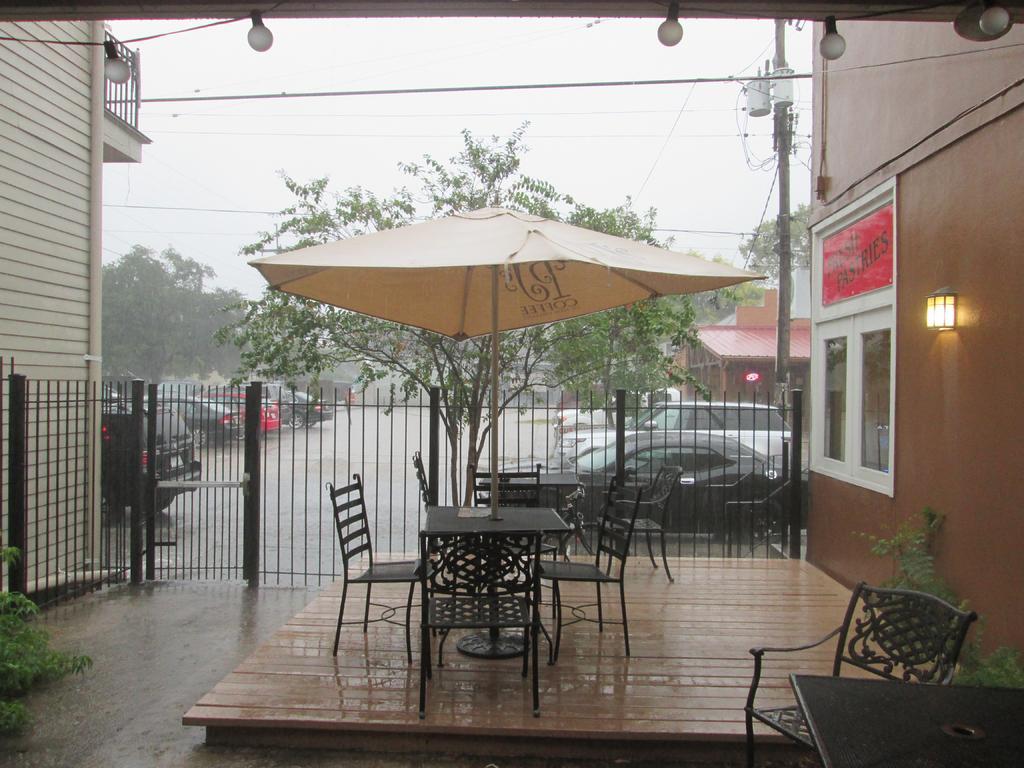Could you give a brief overview of what you see in this image? In this image there is sky, there are trees, there are chairś, there is a table, there is an object on the table, there is an Umbrella, there are lightś, there is a pole, there is a gate, there is road, there are vechileś on the road. 